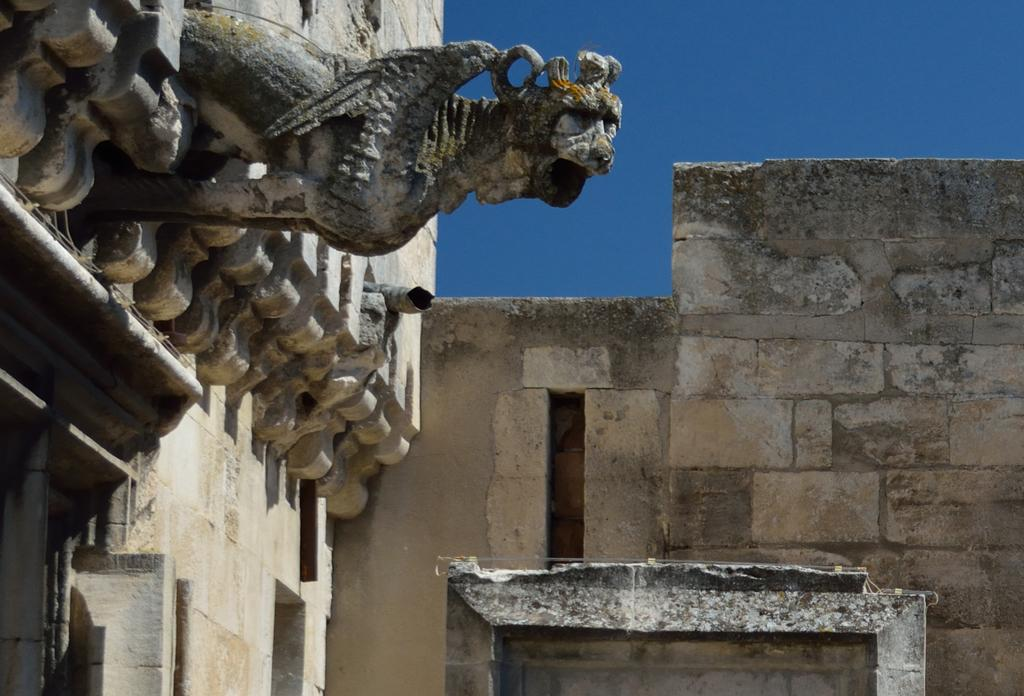What is on the wall in the image? There is a sculpture on the wall in the image. What type of wall is on the right side of the image? There is a stone wall on the right side of the image. What is visible at the top of the image? The sky is visible at the top of the image. What color is the sky in the image? The sky is blue in color. Can you see a shoe covering the sculpture in the image? No, there is no shoe present in the image, and the sculpture is not covered by any object. 